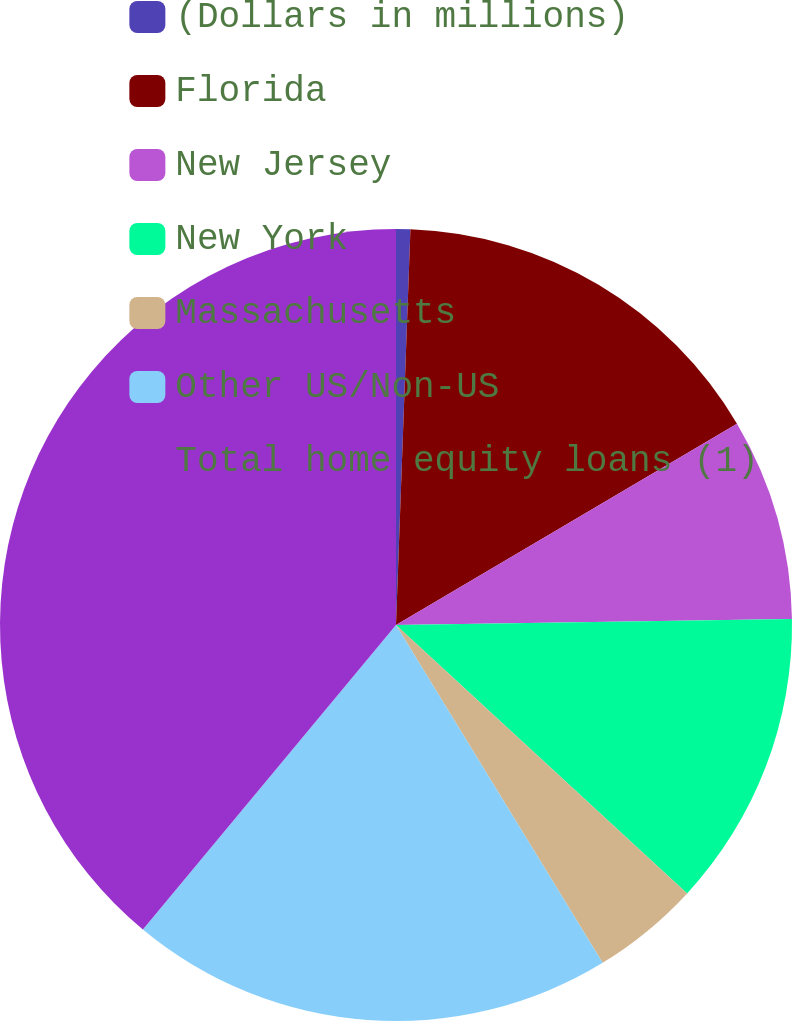Convert chart to OTSL. <chart><loc_0><loc_0><loc_500><loc_500><pie_chart><fcel>(Dollars in millions)<fcel>Florida<fcel>New Jersey<fcel>New York<fcel>Massachusetts<fcel>Other US/Non-US<fcel>Total home equity loans (1)<nl><fcel>0.58%<fcel>15.93%<fcel>8.25%<fcel>12.09%<fcel>4.41%<fcel>19.77%<fcel>38.96%<nl></chart> 